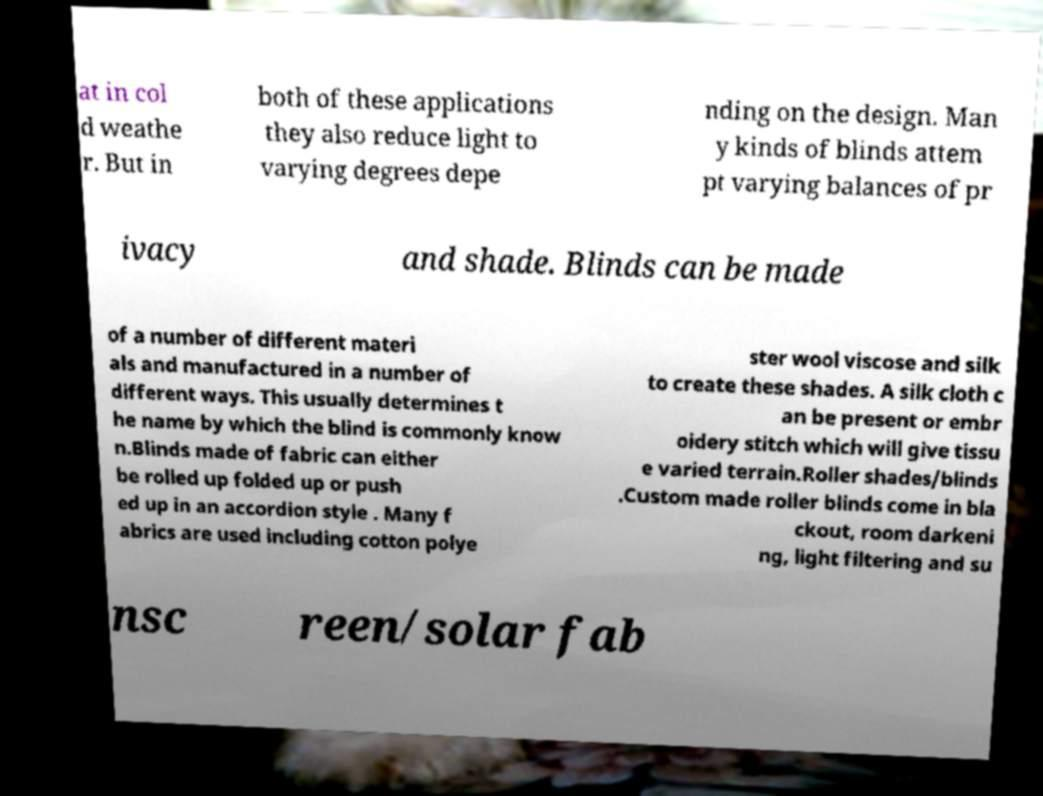Can you read and provide the text displayed in the image?This photo seems to have some interesting text. Can you extract and type it out for me? at in col d weathe r. But in both of these applications they also reduce light to varying degrees depe nding on the design. Man y kinds of blinds attem pt varying balances of pr ivacy and shade. Blinds can be made of a number of different materi als and manufactured in a number of different ways. This usually determines t he name by which the blind is commonly know n.Blinds made of fabric can either be rolled up folded up or push ed up in an accordion style . Many f abrics are used including cotton polye ster wool viscose and silk to create these shades. A silk cloth c an be present or embr oidery stitch which will give tissu e varied terrain.Roller shades/blinds .Custom made roller blinds come in bla ckout, room darkeni ng, light filtering and su nsc reen/solar fab 